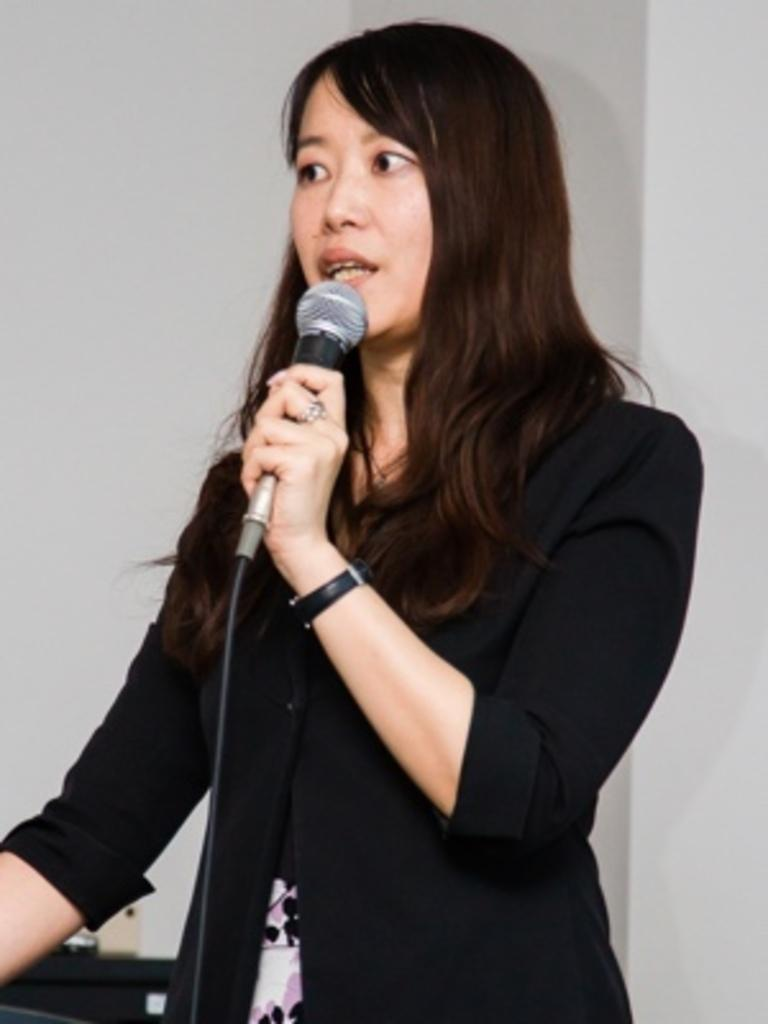Who is the main subject in the image? There is a woman in the image. What is the woman wearing? The woman is wearing a black coat. What is the woman doing in the image? The woman is standing and holding a microphone. What accessory is the woman wearing on her wrist? The woman is wearing a watch. What can be seen in the background of the image? There is a wall in the background of the image. What time of day is it in the image, as indicated by the fireman and morning? There is no fireman or reference to morning in the image; it only features a woman holding a microphone. What is the woman using to sew in the image, as indicated by the needle? There is no needle present in the image; the woman is holding a microphone. 